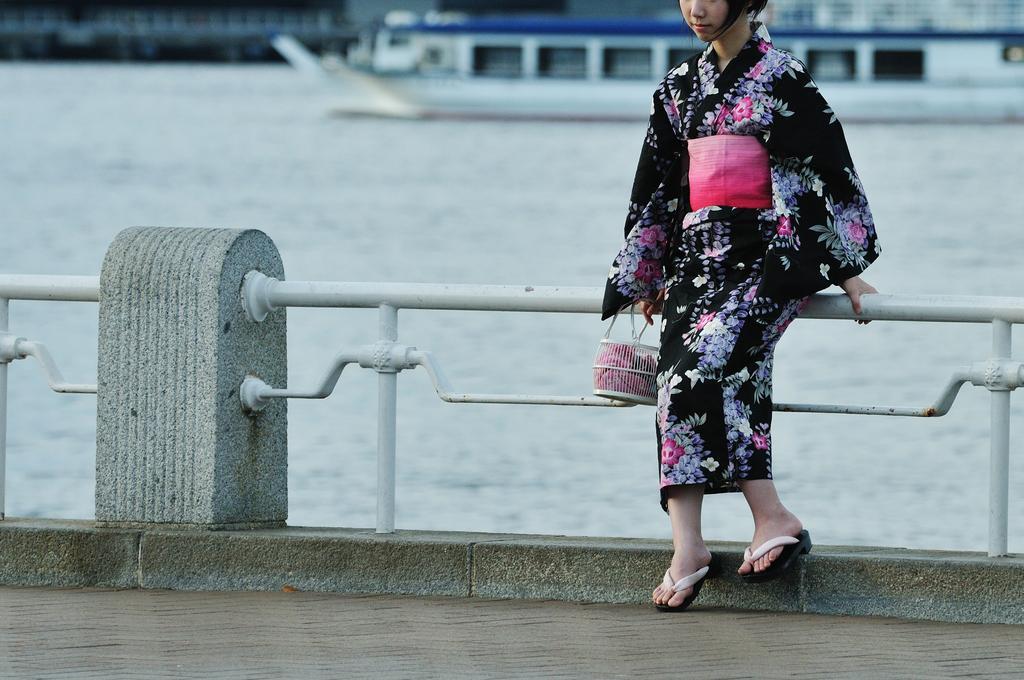Please provide a concise description of this image. In this image there is a lady. There is a railing. In the background of the image there is a ship. There is water. There is road. 